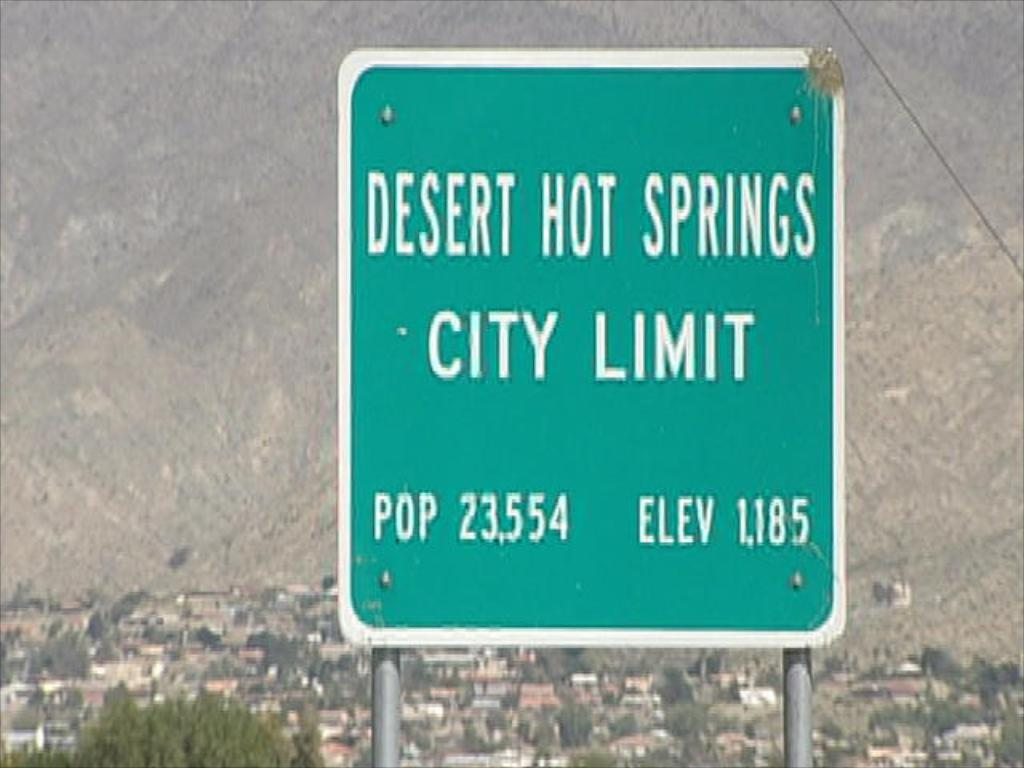<image>
Share a concise interpretation of the image provided. A green sign displays the population and elevation of Desert Hot Springs. 